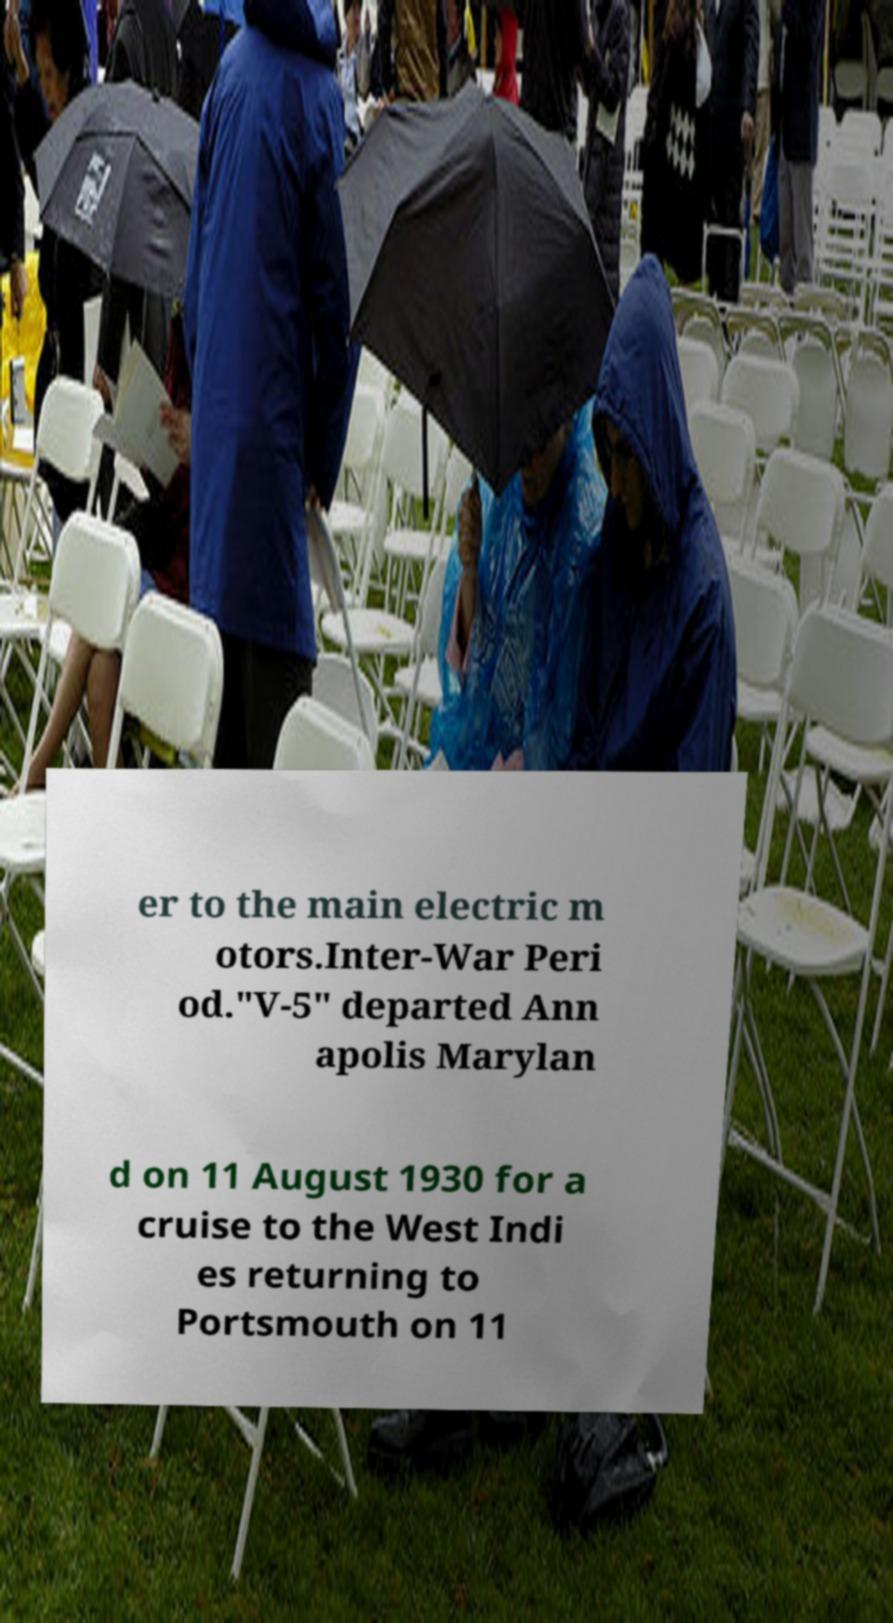Can you accurately transcribe the text from the provided image for me? er to the main electric m otors.Inter-War Peri od."V-5" departed Ann apolis Marylan d on 11 August 1930 for a cruise to the West Indi es returning to Portsmouth on 11 